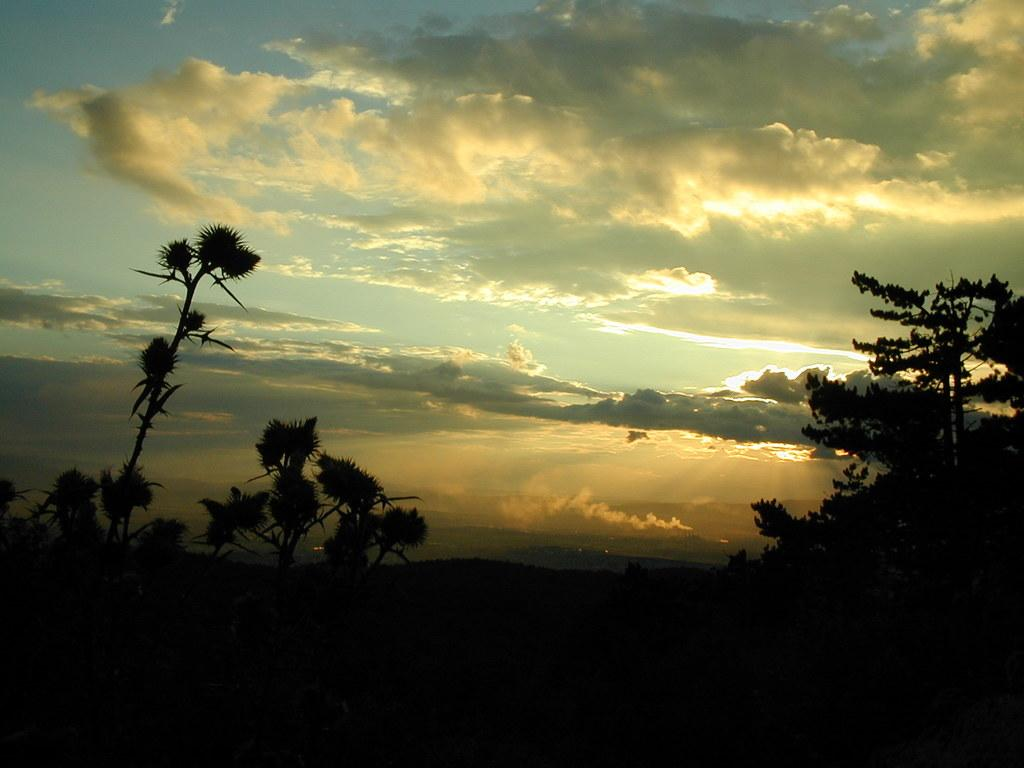What type of natural features can be seen in the image? There are trees and mountains in the image. What is visible at the top of the image? The sky is visible at the top of the image. Where is the writer sitting in the image? There is no writer present in the image. What type of structure can be seen in the image? There is no specific structure mentioned in the provided facts; the image features trees, mountains, and the sky. 